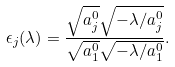<formula> <loc_0><loc_0><loc_500><loc_500>\epsilon _ { j } ( \lambda ) = \frac { \sqrt { a _ { j } ^ { 0 } } \sqrt { - \lambda / a _ { j } ^ { 0 } } } { \sqrt { a _ { 1 } ^ { 0 } } \sqrt { - \lambda / a _ { 1 } ^ { 0 } } } .</formula> 